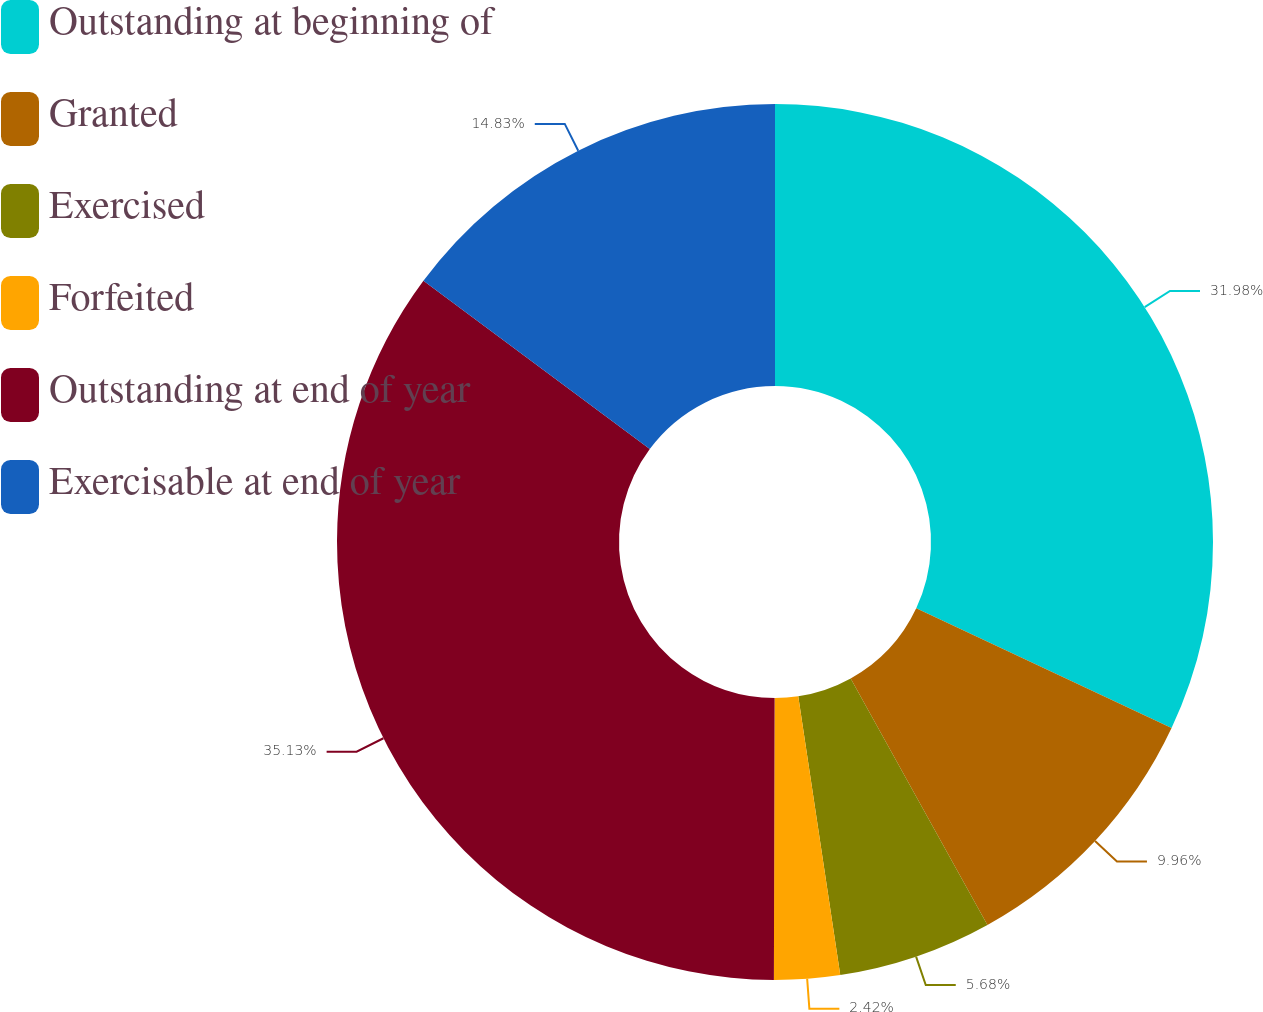<chart> <loc_0><loc_0><loc_500><loc_500><pie_chart><fcel>Outstanding at beginning of<fcel>Granted<fcel>Exercised<fcel>Forfeited<fcel>Outstanding at end of year<fcel>Exercisable at end of year<nl><fcel>31.98%<fcel>9.96%<fcel>5.68%<fcel>2.42%<fcel>35.13%<fcel>14.83%<nl></chart> 